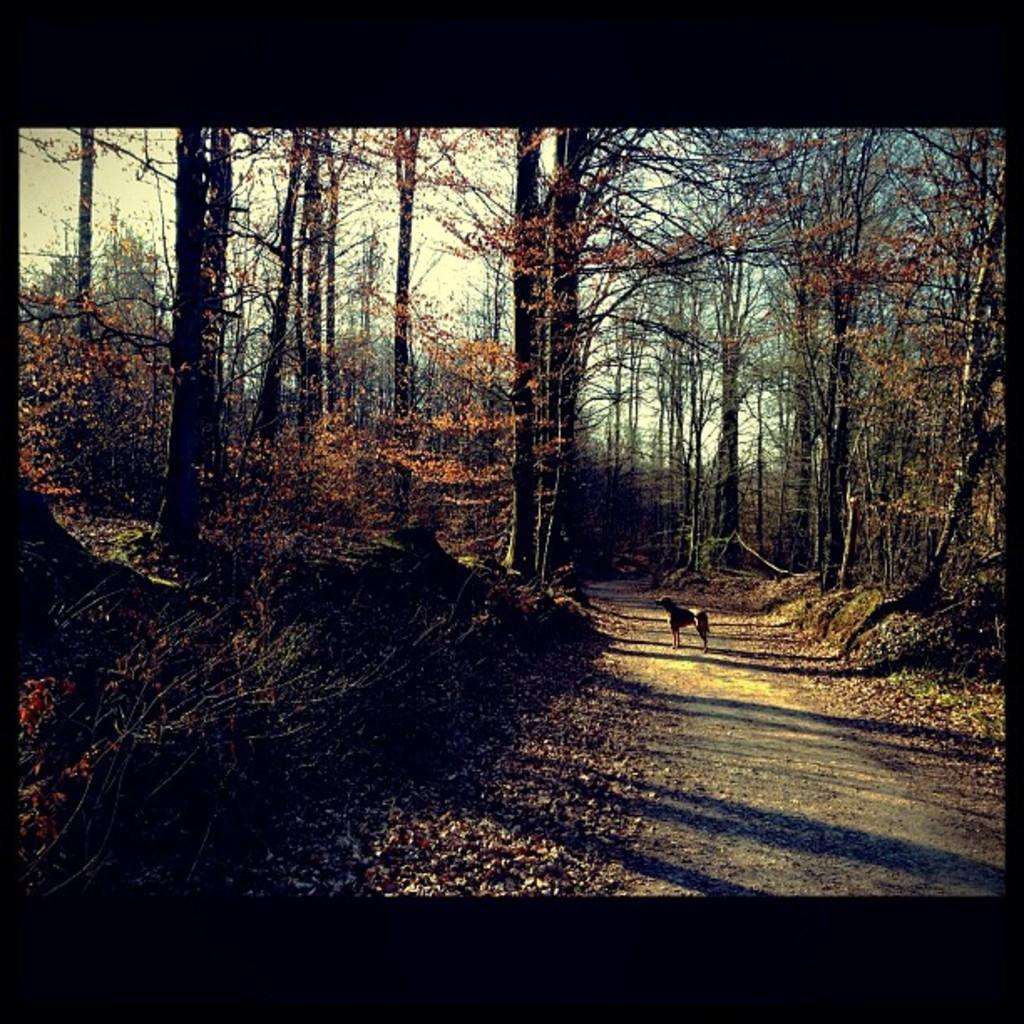Where was the image taken? The image was clicked outside. What can be seen in the middle of the image? There are trees and a dog in the middle of the image. What is visible at the top of the image? The sky is visible at the top of the image. What is the size of the vein visible on the dog's leg in the image? There is no visible vein on the dog's leg in the image. 